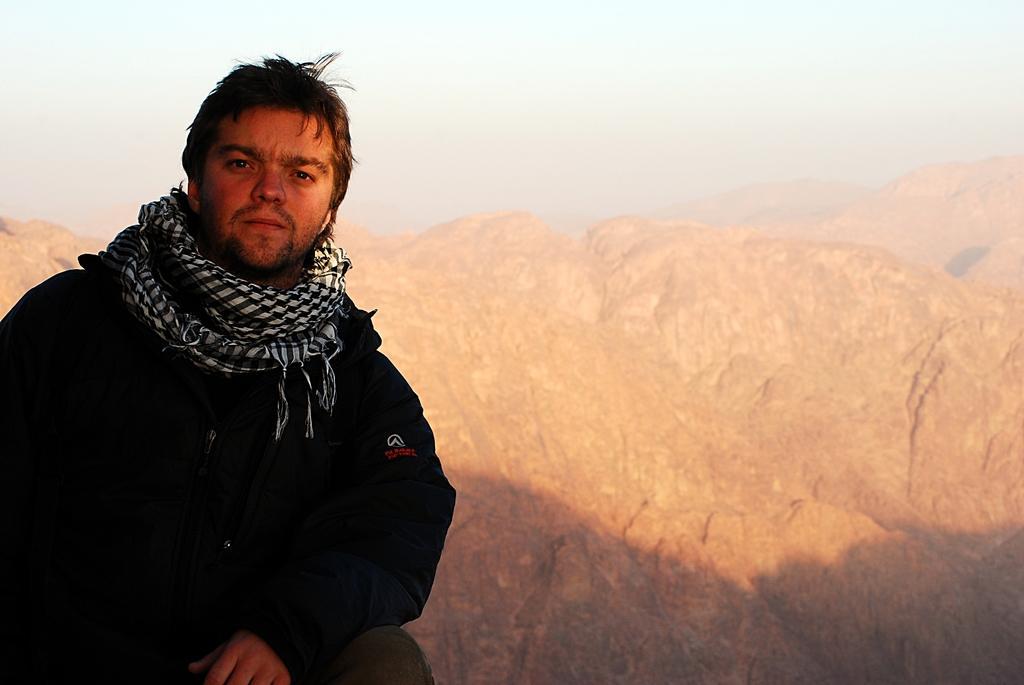Could you give a brief overview of what you see in this image? A person is present at the left wearing a black coat and a stole. There are mountains at the back. 